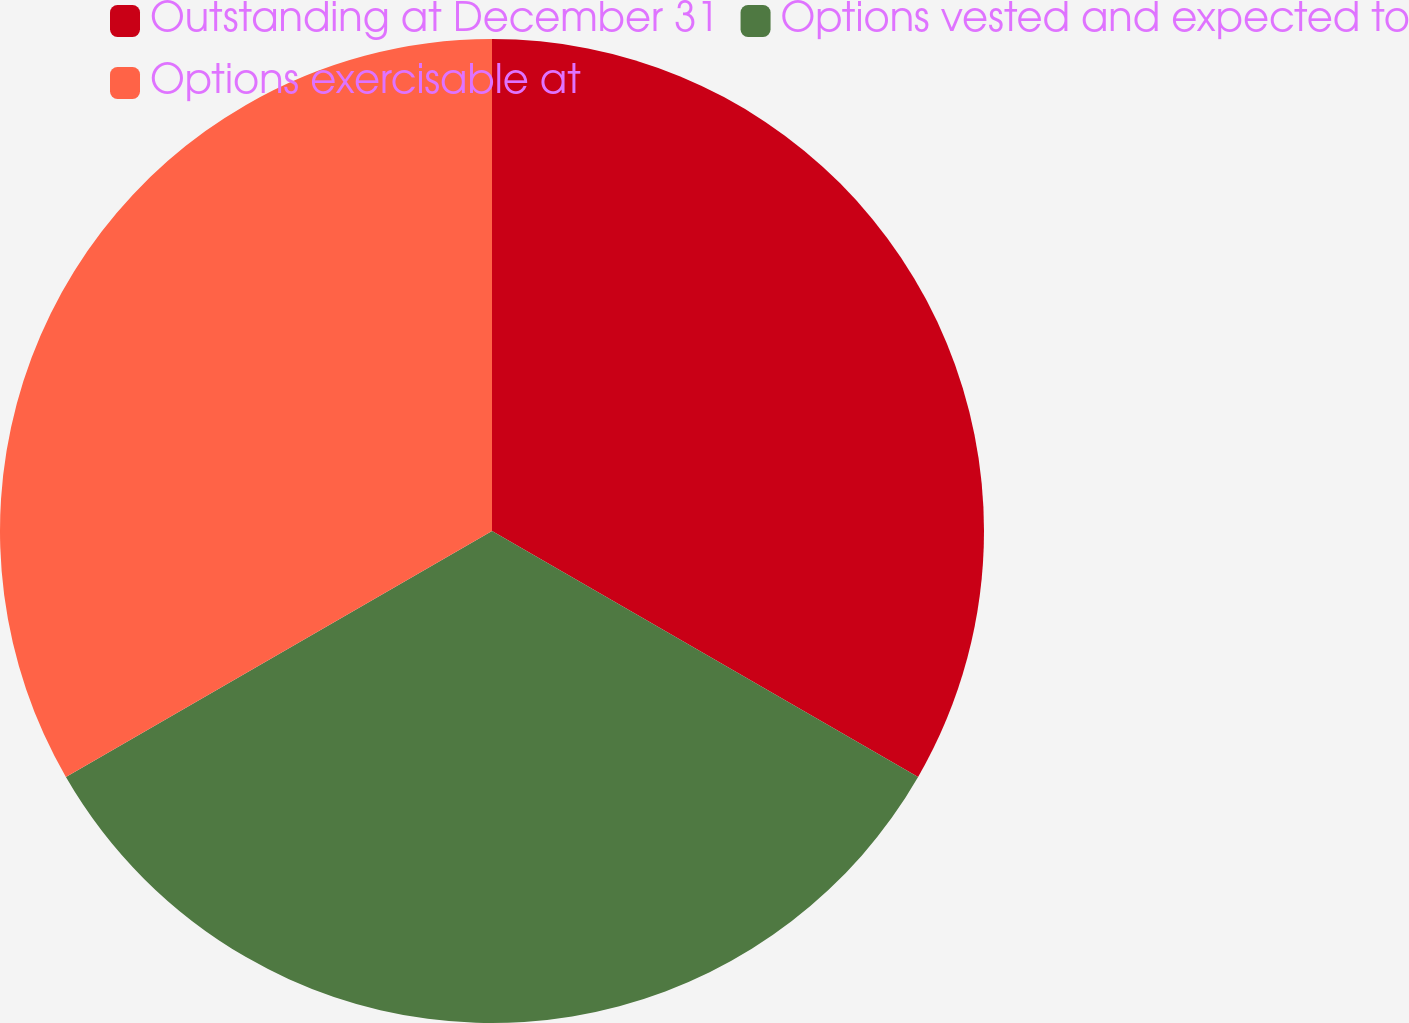<chart> <loc_0><loc_0><loc_500><loc_500><pie_chart><fcel>Outstanding at December 31<fcel>Options vested and expected to<fcel>Options exercisable at<nl><fcel>33.33%<fcel>33.33%<fcel>33.33%<nl></chart> 